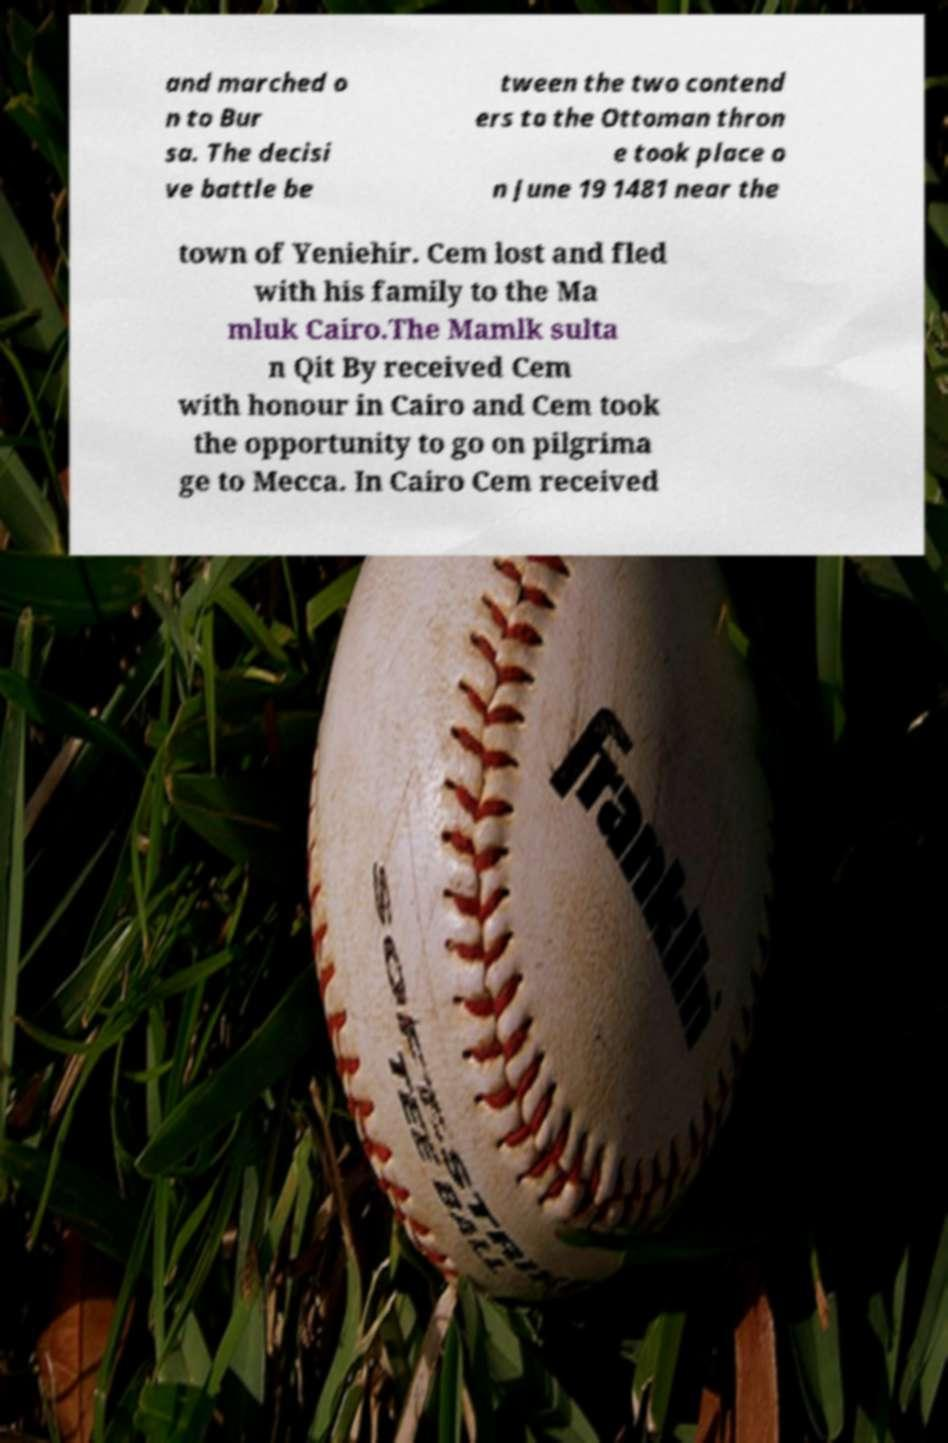What messages or text are displayed in this image? I need them in a readable, typed format. and marched o n to Bur sa. The decisi ve battle be tween the two contend ers to the Ottoman thron e took place o n June 19 1481 near the town of Yeniehir. Cem lost and fled with his family to the Ma mluk Cairo.The Mamlk sulta n Qit By received Cem with honour in Cairo and Cem took the opportunity to go on pilgrima ge to Mecca. In Cairo Cem received 